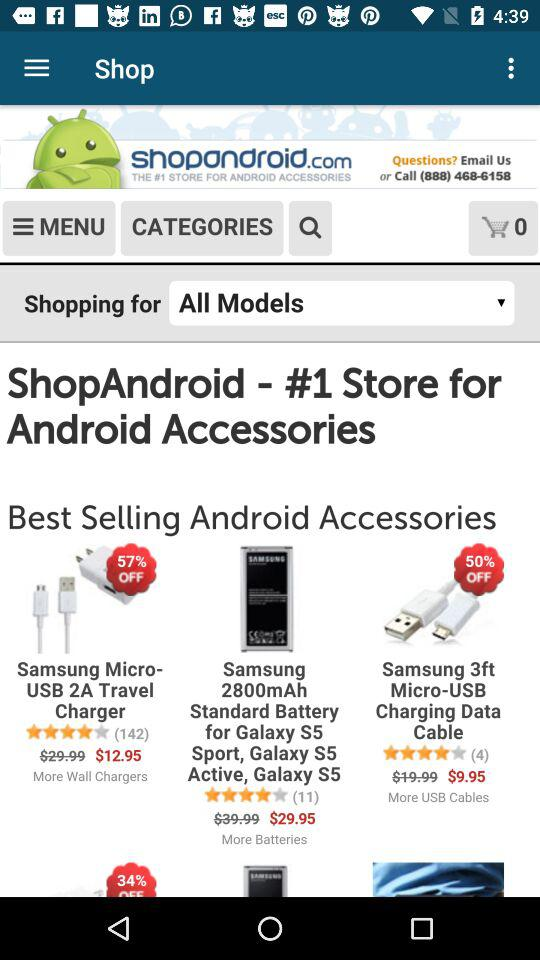How much is the discount on "Samsung 3ft Micro-USB Charging Data Cable"? The discount is 50%. 